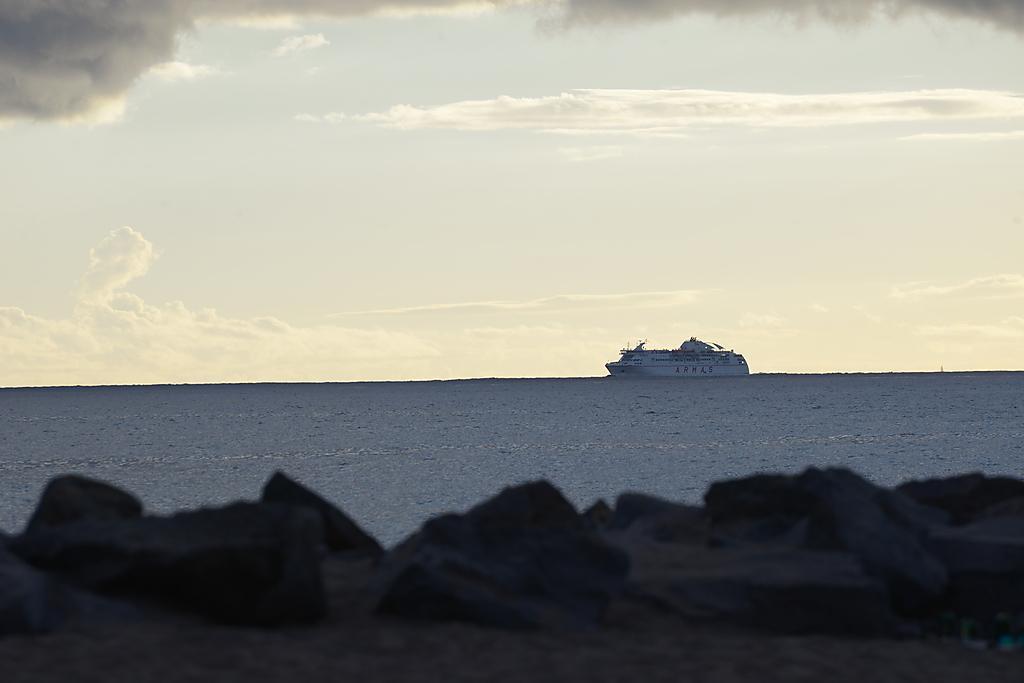Can you describe this image briefly? In this picture we can see white cruise ship in the water. In the front there are some stones. On the top we can see the sky and clouds. 